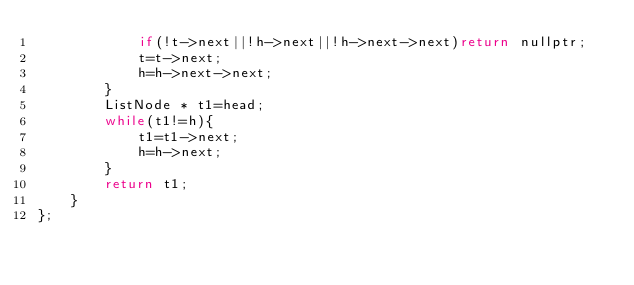Convert code to text. <code><loc_0><loc_0><loc_500><loc_500><_C++_>            if(!t->next||!h->next||!h->next->next)return nullptr;
            t=t->next;
            h=h->next->next;
        }
        ListNode * t1=head;
        while(t1!=h){
            t1=t1->next;
            h=h->next;
        }
        return t1;
    }
};
</code> 